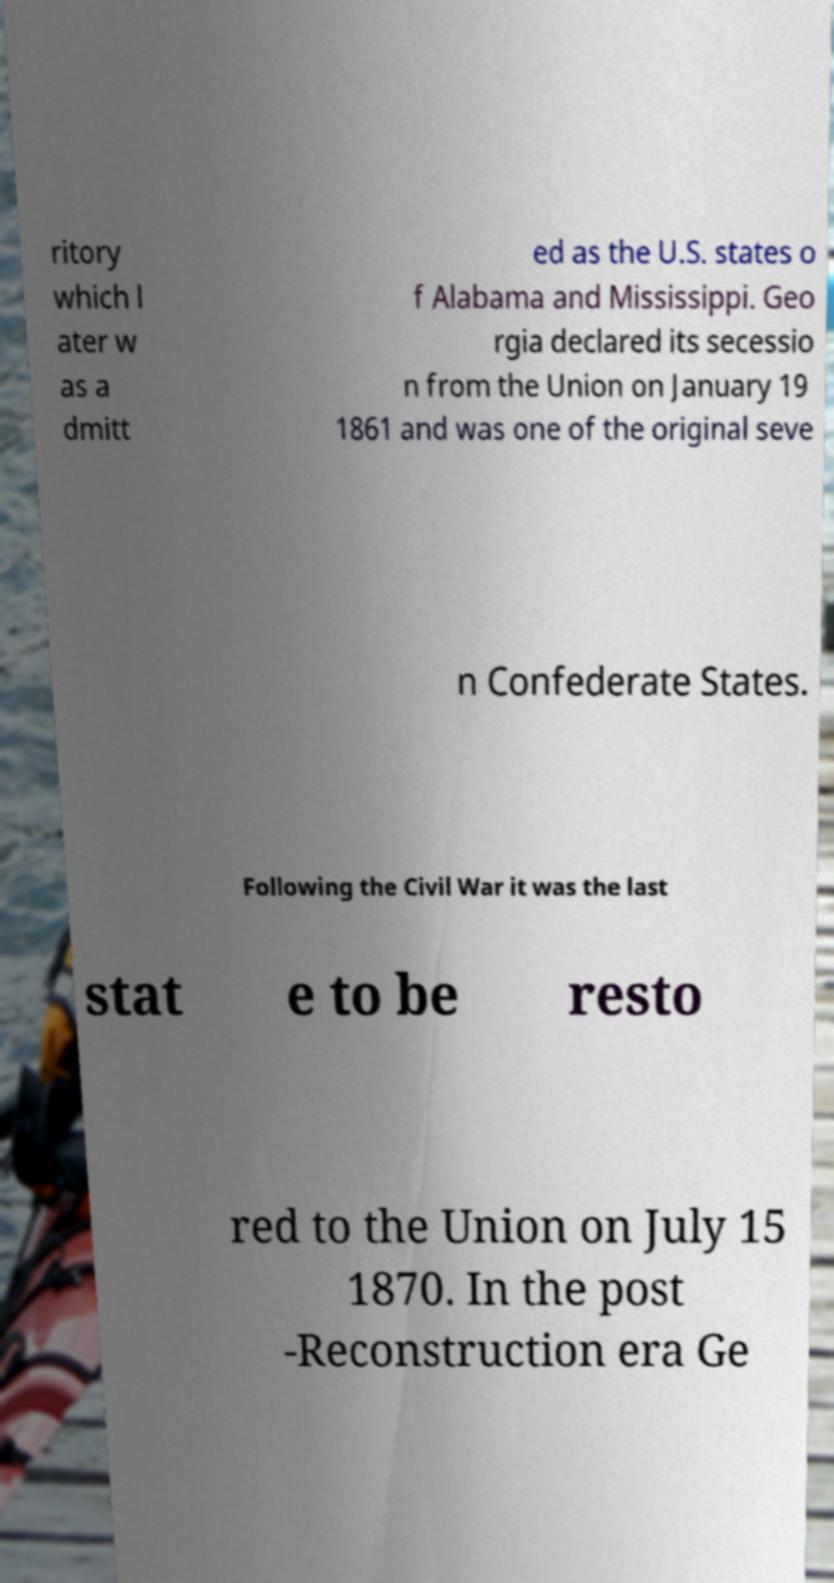There's text embedded in this image that I need extracted. Can you transcribe it verbatim? ritory which l ater w as a dmitt ed as the U.S. states o f Alabama and Mississippi. Geo rgia declared its secessio n from the Union on January 19 1861 and was one of the original seve n Confederate States. Following the Civil War it was the last stat e to be resto red to the Union on July 15 1870. In the post -Reconstruction era Ge 